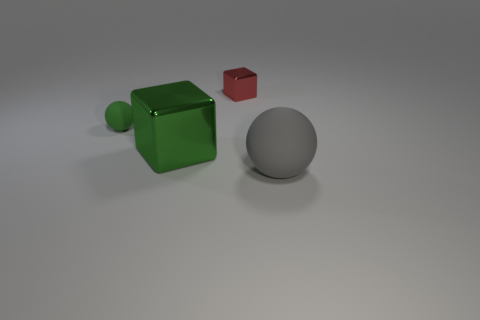What number of other objects are there of the same color as the large sphere?
Your response must be concise. 0. How many brown objects are metallic blocks or large rubber spheres?
Keep it short and to the point. 0. There is a tiny green rubber thing; does it have the same shape as the big thing that is on the right side of the red block?
Your answer should be compact. Yes. What shape is the green metal object?
Keep it short and to the point. Cube. There is a object that is the same size as the green cube; what is it made of?
Provide a short and direct response. Rubber. What number of objects are either large green balls or objects that are in front of the small green rubber sphere?
Provide a short and direct response. 2. What size is the object that is made of the same material as the gray ball?
Your answer should be compact. Small. There is a big object that is right of the large object on the left side of the tiny red block; what is its shape?
Give a very brief answer. Sphere. There is a thing that is both in front of the green rubber thing and on the left side of the gray matte sphere; what is its size?
Offer a terse response. Large. Are there any other matte objects of the same shape as the big gray thing?
Provide a succinct answer. Yes. 